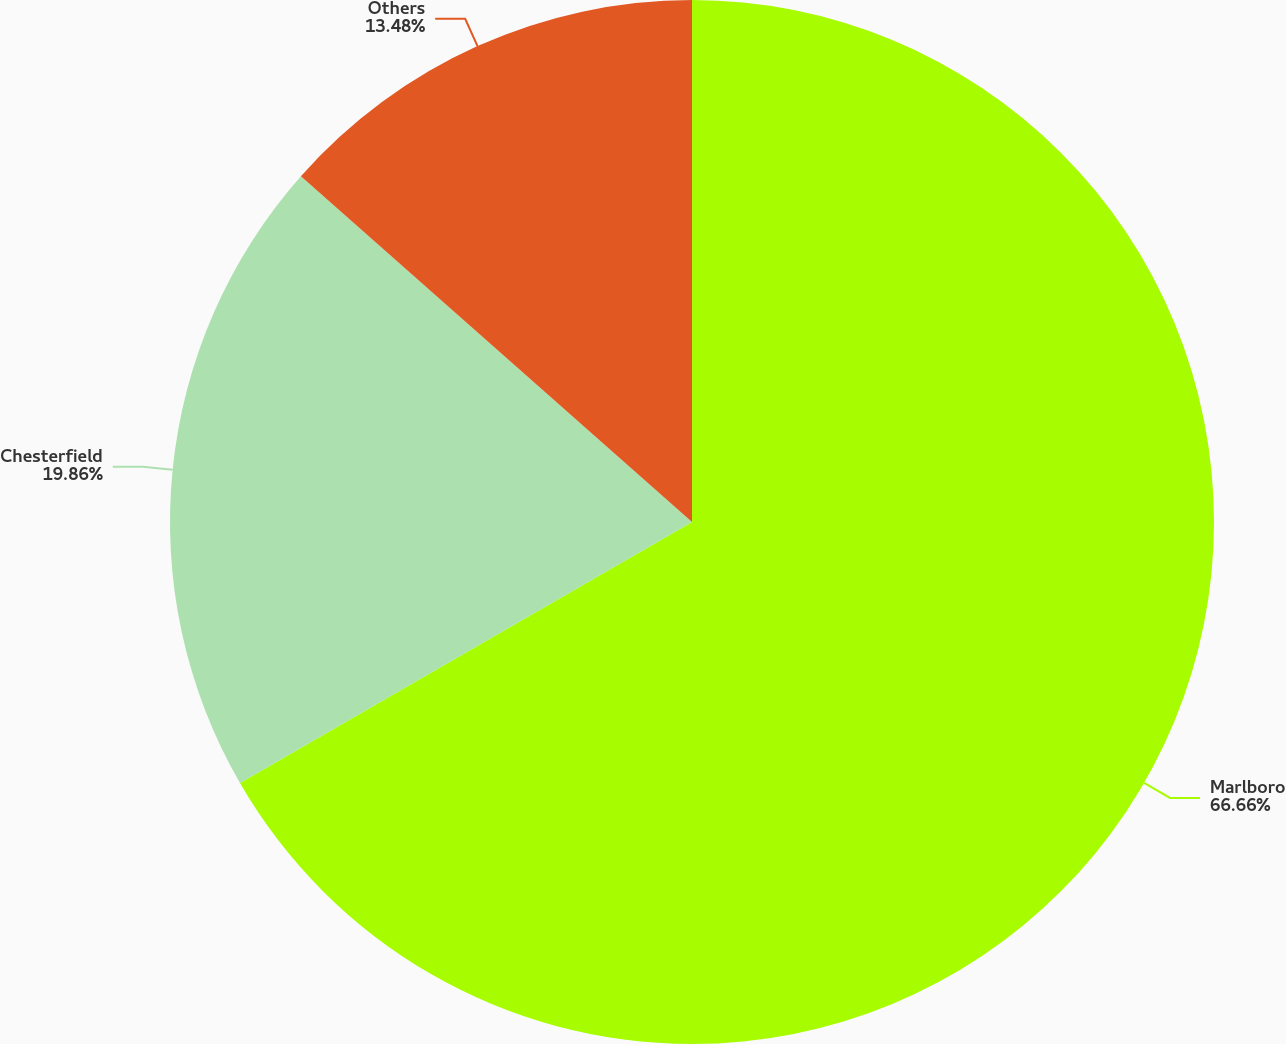Convert chart to OTSL. <chart><loc_0><loc_0><loc_500><loc_500><pie_chart><fcel>Marlboro<fcel>Chesterfield<fcel>Others<nl><fcel>66.67%<fcel>19.86%<fcel>13.48%<nl></chart> 